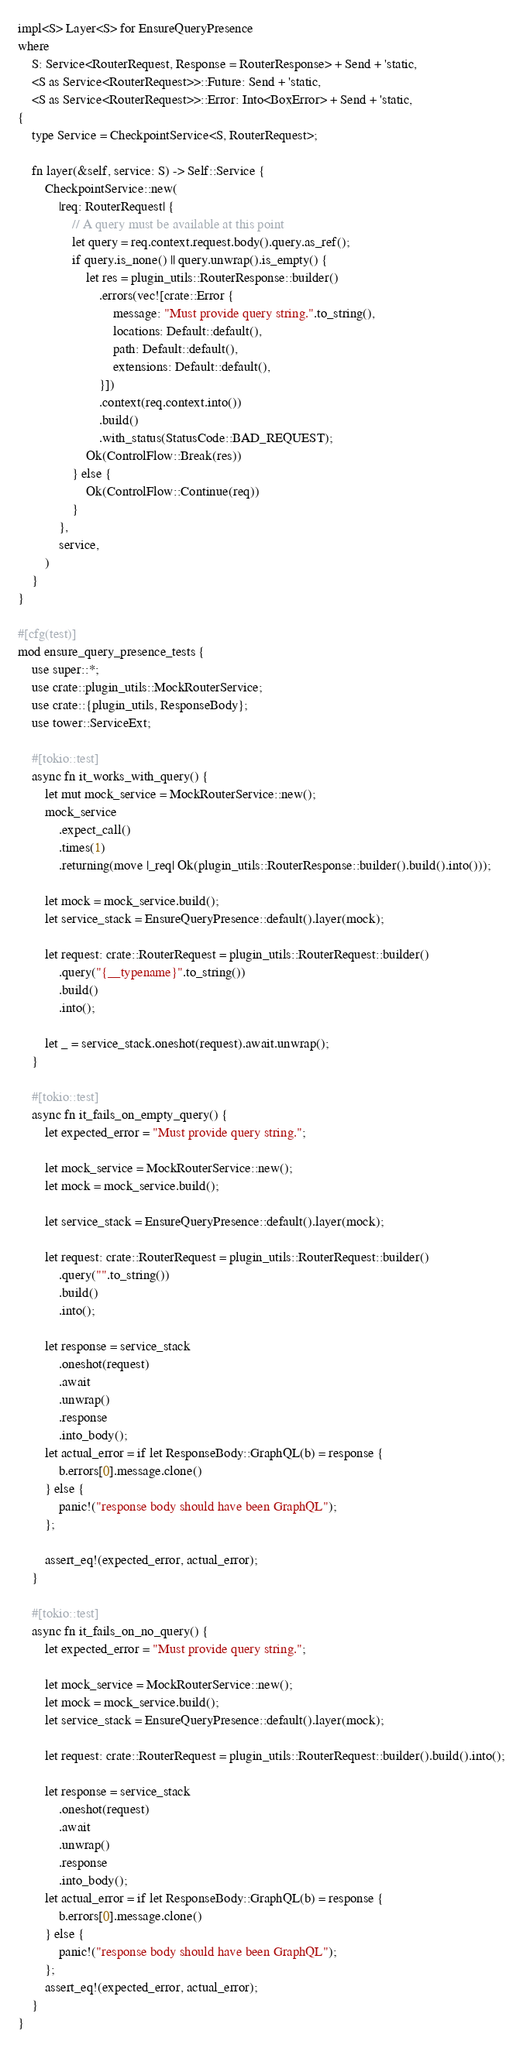Convert code to text. <code><loc_0><loc_0><loc_500><loc_500><_Rust_>impl<S> Layer<S> for EnsureQueryPresence
where
    S: Service<RouterRequest, Response = RouterResponse> + Send + 'static,
    <S as Service<RouterRequest>>::Future: Send + 'static,
    <S as Service<RouterRequest>>::Error: Into<BoxError> + Send + 'static,
{
    type Service = CheckpointService<S, RouterRequest>;

    fn layer(&self, service: S) -> Self::Service {
        CheckpointService::new(
            |req: RouterRequest| {
                // A query must be available at this point
                let query = req.context.request.body().query.as_ref();
                if query.is_none() || query.unwrap().is_empty() {
                    let res = plugin_utils::RouterResponse::builder()
                        .errors(vec![crate::Error {
                            message: "Must provide query string.".to_string(),
                            locations: Default::default(),
                            path: Default::default(),
                            extensions: Default::default(),
                        }])
                        .context(req.context.into())
                        .build()
                        .with_status(StatusCode::BAD_REQUEST);
                    Ok(ControlFlow::Break(res))
                } else {
                    Ok(ControlFlow::Continue(req))
                }
            },
            service,
        )
    }
}

#[cfg(test)]
mod ensure_query_presence_tests {
    use super::*;
    use crate::plugin_utils::MockRouterService;
    use crate::{plugin_utils, ResponseBody};
    use tower::ServiceExt;

    #[tokio::test]
    async fn it_works_with_query() {
        let mut mock_service = MockRouterService::new();
        mock_service
            .expect_call()
            .times(1)
            .returning(move |_req| Ok(plugin_utils::RouterResponse::builder().build().into()));

        let mock = mock_service.build();
        let service_stack = EnsureQueryPresence::default().layer(mock);

        let request: crate::RouterRequest = plugin_utils::RouterRequest::builder()
            .query("{__typename}".to_string())
            .build()
            .into();

        let _ = service_stack.oneshot(request).await.unwrap();
    }

    #[tokio::test]
    async fn it_fails_on_empty_query() {
        let expected_error = "Must provide query string.";

        let mock_service = MockRouterService::new();
        let mock = mock_service.build();

        let service_stack = EnsureQueryPresence::default().layer(mock);

        let request: crate::RouterRequest = plugin_utils::RouterRequest::builder()
            .query("".to_string())
            .build()
            .into();

        let response = service_stack
            .oneshot(request)
            .await
            .unwrap()
            .response
            .into_body();
        let actual_error = if let ResponseBody::GraphQL(b) = response {
            b.errors[0].message.clone()
        } else {
            panic!("response body should have been GraphQL");
        };

        assert_eq!(expected_error, actual_error);
    }

    #[tokio::test]
    async fn it_fails_on_no_query() {
        let expected_error = "Must provide query string.";

        let mock_service = MockRouterService::new();
        let mock = mock_service.build();
        let service_stack = EnsureQueryPresence::default().layer(mock);

        let request: crate::RouterRequest = plugin_utils::RouterRequest::builder().build().into();

        let response = service_stack
            .oneshot(request)
            .await
            .unwrap()
            .response
            .into_body();
        let actual_error = if let ResponseBody::GraphQL(b) = response {
            b.errors[0].message.clone()
        } else {
            panic!("response body should have been GraphQL");
        };
        assert_eq!(expected_error, actual_error);
    }
}
</code> 